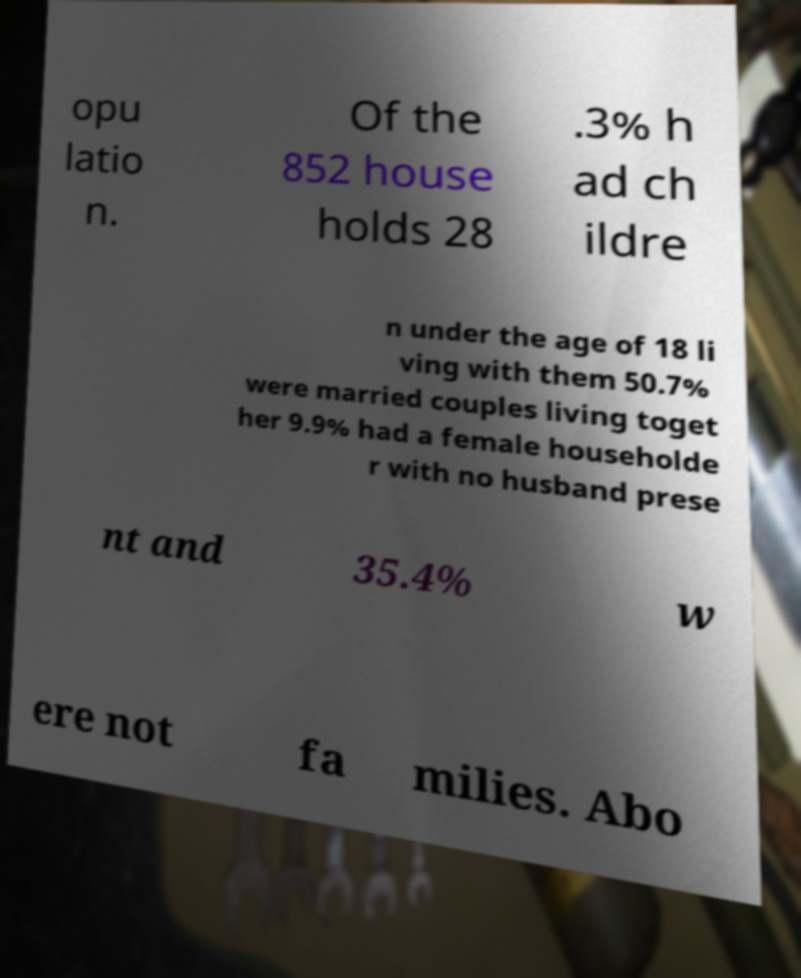For documentation purposes, I need the text within this image transcribed. Could you provide that? opu latio n. Of the 852 house holds 28 .3% h ad ch ildre n under the age of 18 li ving with them 50.7% were married couples living toget her 9.9% had a female householde r with no husband prese nt and 35.4% w ere not fa milies. Abo 